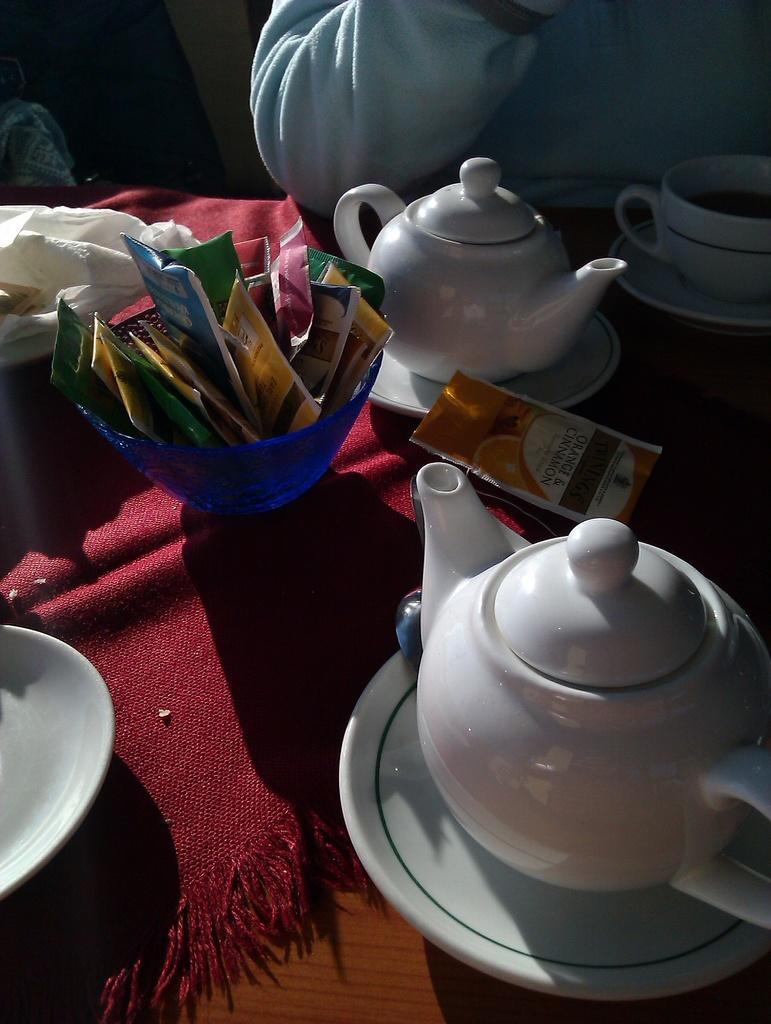What objects are on the table in the image? There are bowls on a table in the image. Can you describe the person visible in the background of the image? Unfortunately, the provided facts do not give any information about the person in the background. Reasoning: Let' the distance from the table? What type of copper material is being used to provide shade in the image? There is no mention of copper or shade in the provided facts, so this question cannot be answered based on the information given. 